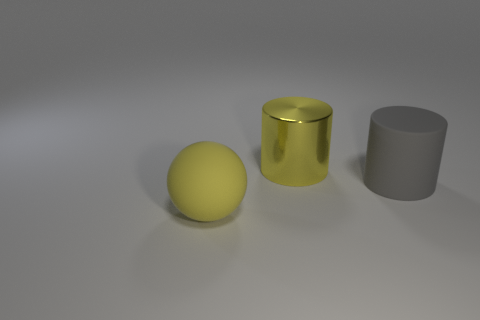Is the number of large yellow shiny cylinders behind the rubber sphere the same as the number of tiny blocks?
Your answer should be compact. No. What number of big objects are both to the left of the rubber cylinder and behind the big yellow matte object?
Your response must be concise. 1. What number of other big gray objects are the same shape as the metal object?
Make the answer very short. 1. Are there more big rubber spheres that are to the left of the big yellow rubber object than large yellow metallic things?
Make the answer very short. No. The large object that is in front of the yellow metallic cylinder and to the left of the large gray rubber cylinder has what shape?
Keep it short and to the point. Sphere. Is the yellow matte sphere the same size as the gray object?
Your answer should be very brief. Yes. There is a large yellow metallic object; what number of yellow metal objects are behind it?
Your response must be concise. 0. Are there an equal number of big things that are in front of the large rubber ball and rubber cylinders that are in front of the yellow metallic object?
Give a very brief answer. No. There is a large yellow object behind the large gray matte cylinder; is its shape the same as the gray thing?
Offer a very short reply. Yes. Is there anything else that has the same material as the yellow cylinder?
Provide a short and direct response. No. 